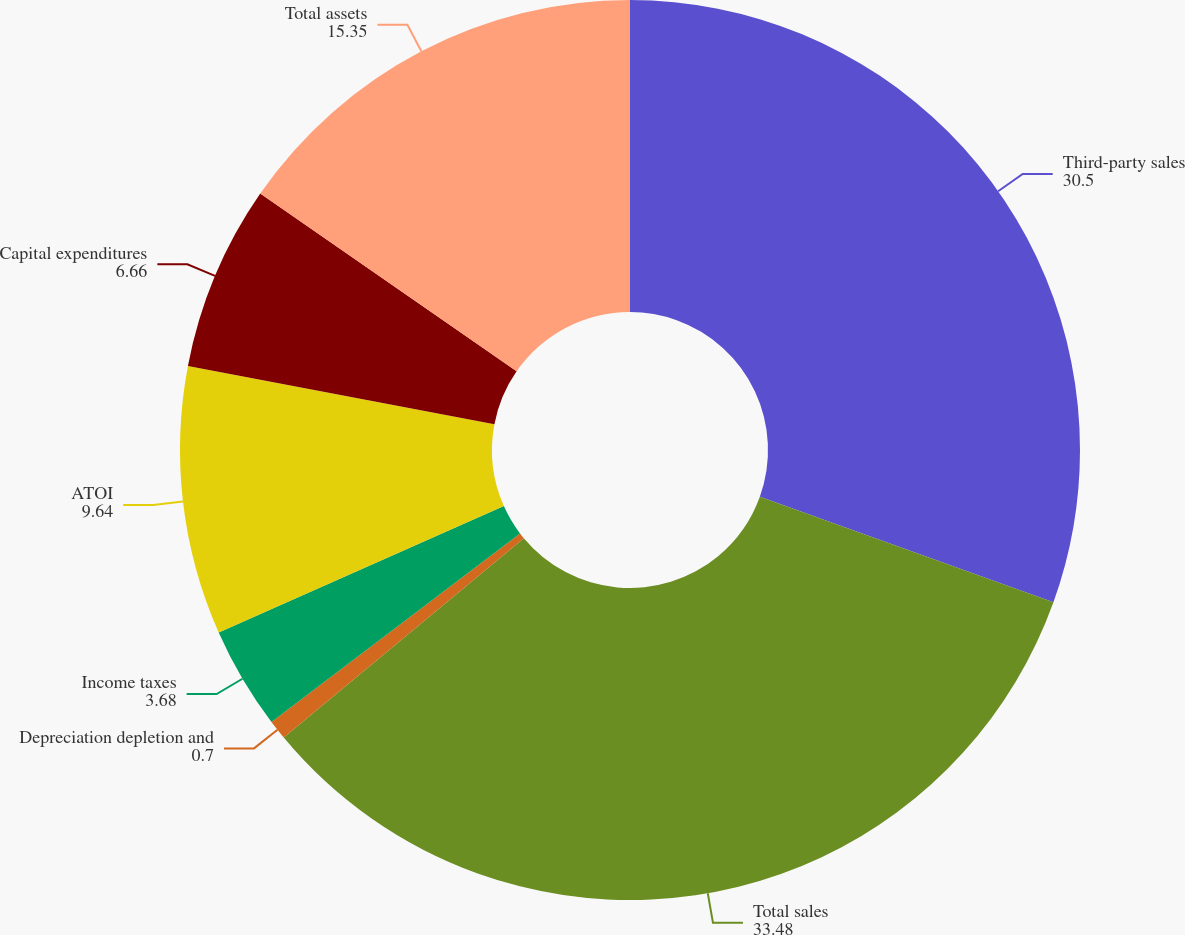<chart> <loc_0><loc_0><loc_500><loc_500><pie_chart><fcel>Third-party sales<fcel>Total sales<fcel>Depreciation depletion and<fcel>Income taxes<fcel>ATOI<fcel>Capital expenditures<fcel>Total assets<nl><fcel>30.5%<fcel>33.48%<fcel>0.7%<fcel>3.68%<fcel>9.64%<fcel>6.66%<fcel>15.35%<nl></chart> 